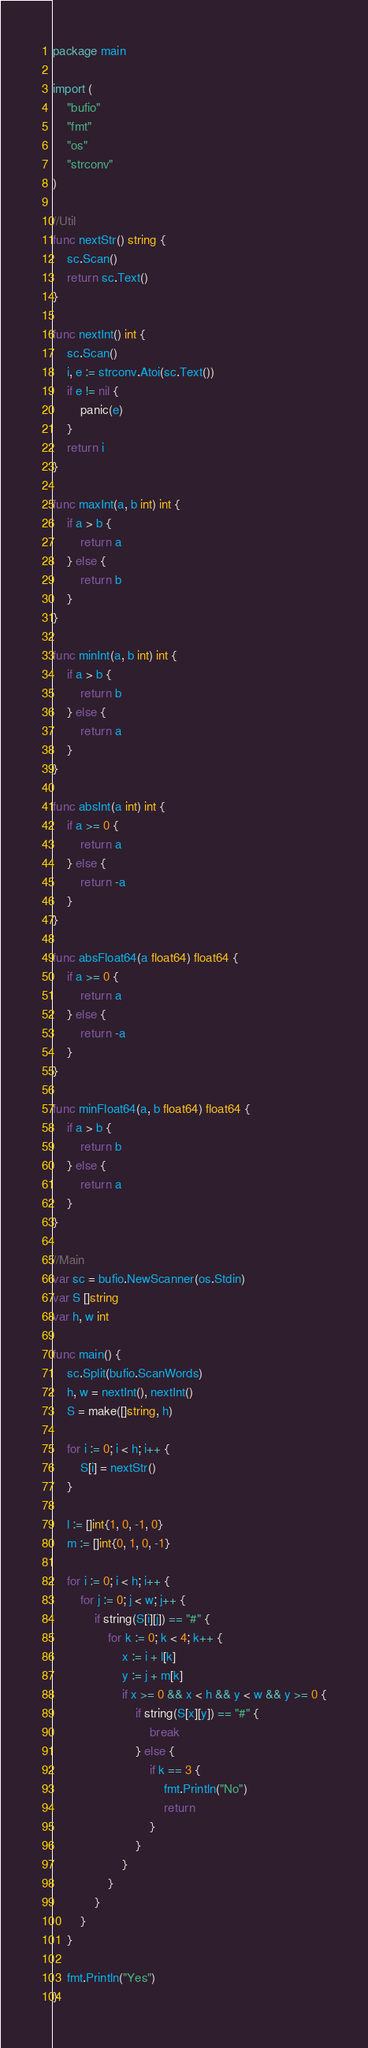<code> <loc_0><loc_0><loc_500><loc_500><_Go_>package main

import (
	"bufio"
	"fmt"
	"os"
	"strconv"
)

//Util
func nextStr() string {
	sc.Scan()
	return sc.Text()
}

func nextInt() int {
	sc.Scan()
	i, e := strconv.Atoi(sc.Text())
	if e != nil {
		panic(e)
	}
	return i
}

func maxInt(a, b int) int {
	if a > b {
		return a
	} else {
		return b
	}
}

func minInt(a, b int) int {
	if a > b {
		return b
	} else {
		return a
	}
}

func absInt(a int) int {
	if a >= 0 {
		return a
	} else {
		return -a
	}
}

func absFloat64(a float64) float64 {
	if a >= 0 {
		return a
	} else {
		return -a
	}
}

func minFloat64(a, b float64) float64 {
	if a > b {
		return b
	} else {
		return a
	}
}

//Main
var sc = bufio.NewScanner(os.Stdin)
var S []string
var h, w int

func main() {
	sc.Split(bufio.ScanWords)
	h, w = nextInt(), nextInt()
	S = make([]string, h)

	for i := 0; i < h; i++ {
		S[i] = nextStr()
	}

	l := []int{1, 0, -1, 0}
	m := []int{0, 1, 0, -1}

	for i := 0; i < h; i++ {
		for j := 0; j < w; j++ {
			if string(S[i][j]) == "#" {
				for k := 0; k < 4; k++ {
					x := i + l[k]
					y := j + m[k]
					if x >= 0 && x < h && y < w && y >= 0 {
						if string(S[x][y]) == "#" {
							break
						} else {
							if k == 3 {
								fmt.Println("No")
								return
							}
						}
					}
				}
			}
		}
	}

	fmt.Println("Yes")
}
</code> 